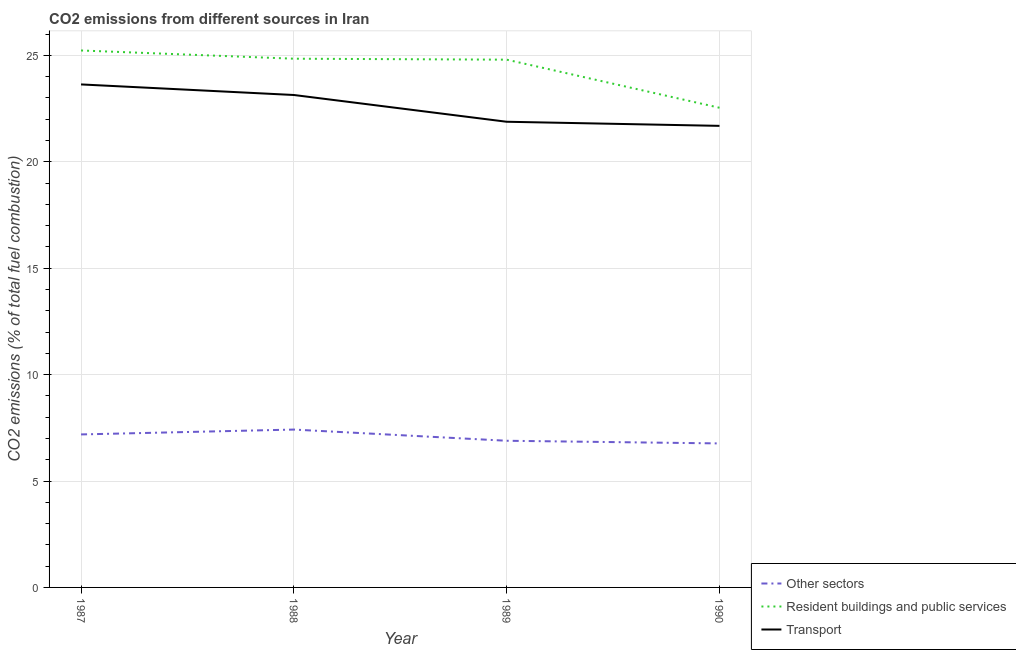What is the percentage of co2 emissions from other sectors in 1989?
Make the answer very short. 6.89. Across all years, what is the maximum percentage of co2 emissions from resident buildings and public services?
Keep it short and to the point. 25.23. Across all years, what is the minimum percentage of co2 emissions from resident buildings and public services?
Give a very brief answer. 22.54. What is the total percentage of co2 emissions from transport in the graph?
Your answer should be compact. 90.33. What is the difference between the percentage of co2 emissions from other sectors in 1988 and that in 1989?
Your answer should be very brief. 0.53. What is the difference between the percentage of co2 emissions from transport in 1988 and the percentage of co2 emissions from resident buildings and public services in 1987?
Provide a succinct answer. -2.09. What is the average percentage of co2 emissions from resident buildings and public services per year?
Offer a very short reply. 24.35. In the year 1989, what is the difference between the percentage of co2 emissions from other sectors and percentage of co2 emissions from transport?
Give a very brief answer. -14.99. What is the ratio of the percentage of co2 emissions from other sectors in 1988 to that in 1989?
Ensure brevity in your answer.  1.08. What is the difference between the highest and the second highest percentage of co2 emissions from other sectors?
Provide a short and direct response. 0.23. What is the difference between the highest and the lowest percentage of co2 emissions from other sectors?
Offer a very short reply. 0.65. Does the percentage of co2 emissions from other sectors monotonically increase over the years?
Provide a succinct answer. No. Is the percentage of co2 emissions from transport strictly greater than the percentage of co2 emissions from other sectors over the years?
Provide a short and direct response. Yes. How many lines are there?
Provide a succinct answer. 3. What is the difference between two consecutive major ticks on the Y-axis?
Give a very brief answer. 5. Does the graph contain any zero values?
Offer a terse response. No. Does the graph contain grids?
Offer a very short reply. Yes. Where does the legend appear in the graph?
Your answer should be very brief. Bottom right. How are the legend labels stacked?
Your answer should be compact. Vertical. What is the title of the graph?
Offer a terse response. CO2 emissions from different sources in Iran. What is the label or title of the X-axis?
Give a very brief answer. Year. What is the label or title of the Y-axis?
Your response must be concise. CO2 emissions (% of total fuel combustion). What is the CO2 emissions (% of total fuel combustion) of Other sectors in 1987?
Provide a succinct answer. 7.19. What is the CO2 emissions (% of total fuel combustion) in Resident buildings and public services in 1987?
Your answer should be very brief. 25.23. What is the CO2 emissions (% of total fuel combustion) in Transport in 1987?
Offer a very short reply. 23.63. What is the CO2 emissions (% of total fuel combustion) in Other sectors in 1988?
Keep it short and to the point. 7.42. What is the CO2 emissions (% of total fuel combustion) in Resident buildings and public services in 1988?
Provide a succinct answer. 24.84. What is the CO2 emissions (% of total fuel combustion) of Transport in 1988?
Make the answer very short. 23.14. What is the CO2 emissions (% of total fuel combustion) of Other sectors in 1989?
Offer a very short reply. 6.89. What is the CO2 emissions (% of total fuel combustion) of Resident buildings and public services in 1989?
Your answer should be very brief. 24.8. What is the CO2 emissions (% of total fuel combustion) in Transport in 1989?
Provide a succinct answer. 21.88. What is the CO2 emissions (% of total fuel combustion) of Other sectors in 1990?
Give a very brief answer. 6.77. What is the CO2 emissions (% of total fuel combustion) in Resident buildings and public services in 1990?
Ensure brevity in your answer.  22.54. What is the CO2 emissions (% of total fuel combustion) of Transport in 1990?
Your answer should be very brief. 21.69. Across all years, what is the maximum CO2 emissions (% of total fuel combustion) in Other sectors?
Keep it short and to the point. 7.42. Across all years, what is the maximum CO2 emissions (% of total fuel combustion) in Resident buildings and public services?
Offer a terse response. 25.23. Across all years, what is the maximum CO2 emissions (% of total fuel combustion) of Transport?
Provide a succinct answer. 23.63. Across all years, what is the minimum CO2 emissions (% of total fuel combustion) in Other sectors?
Give a very brief answer. 6.77. Across all years, what is the minimum CO2 emissions (% of total fuel combustion) in Resident buildings and public services?
Give a very brief answer. 22.54. Across all years, what is the minimum CO2 emissions (% of total fuel combustion) of Transport?
Offer a terse response. 21.69. What is the total CO2 emissions (% of total fuel combustion) of Other sectors in the graph?
Offer a very short reply. 28.26. What is the total CO2 emissions (% of total fuel combustion) of Resident buildings and public services in the graph?
Your response must be concise. 97.4. What is the total CO2 emissions (% of total fuel combustion) in Transport in the graph?
Make the answer very short. 90.33. What is the difference between the CO2 emissions (% of total fuel combustion) in Other sectors in 1987 and that in 1988?
Offer a terse response. -0.23. What is the difference between the CO2 emissions (% of total fuel combustion) in Resident buildings and public services in 1987 and that in 1988?
Keep it short and to the point. 0.39. What is the difference between the CO2 emissions (% of total fuel combustion) in Transport in 1987 and that in 1988?
Your response must be concise. 0.5. What is the difference between the CO2 emissions (% of total fuel combustion) in Other sectors in 1987 and that in 1989?
Your answer should be compact. 0.3. What is the difference between the CO2 emissions (% of total fuel combustion) in Resident buildings and public services in 1987 and that in 1989?
Make the answer very short. 0.43. What is the difference between the CO2 emissions (% of total fuel combustion) of Transport in 1987 and that in 1989?
Make the answer very short. 1.75. What is the difference between the CO2 emissions (% of total fuel combustion) in Other sectors in 1987 and that in 1990?
Make the answer very short. 0.42. What is the difference between the CO2 emissions (% of total fuel combustion) in Resident buildings and public services in 1987 and that in 1990?
Keep it short and to the point. 2.69. What is the difference between the CO2 emissions (% of total fuel combustion) in Transport in 1987 and that in 1990?
Offer a terse response. 1.95. What is the difference between the CO2 emissions (% of total fuel combustion) of Other sectors in 1988 and that in 1989?
Provide a succinct answer. 0.53. What is the difference between the CO2 emissions (% of total fuel combustion) of Resident buildings and public services in 1988 and that in 1989?
Ensure brevity in your answer.  0.04. What is the difference between the CO2 emissions (% of total fuel combustion) of Transport in 1988 and that in 1989?
Provide a succinct answer. 1.26. What is the difference between the CO2 emissions (% of total fuel combustion) of Other sectors in 1988 and that in 1990?
Provide a short and direct response. 0.65. What is the difference between the CO2 emissions (% of total fuel combustion) of Resident buildings and public services in 1988 and that in 1990?
Your response must be concise. 2.3. What is the difference between the CO2 emissions (% of total fuel combustion) of Transport in 1988 and that in 1990?
Keep it short and to the point. 1.45. What is the difference between the CO2 emissions (% of total fuel combustion) in Other sectors in 1989 and that in 1990?
Provide a short and direct response. 0.12. What is the difference between the CO2 emissions (% of total fuel combustion) in Resident buildings and public services in 1989 and that in 1990?
Your answer should be very brief. 2.26. What is the difference between the CO2 emissions (% of total fuel combustion) of Transport in 1989 and that in 1990?
Your answer should be compact. 0.19. What is the difference between the CO2 emissions (% of total fuel combustion) in Other sectors in 1987 and the CO2 emissions (% of total fuel combustion) in Resident buildings and public services in 1988?
Your response must be concise. -17.65. What is the difference between the CO2 emissions (% of total fuel combustion) of Other sectors in 1987 and the CO2 emissions (% of total fuel combustion) of Transport in 1988?
Provide a succinct answer. -15.95. What is the difference between the CO2 emissions (% of total fuel combustion) of Resident buildings and public services in 1987 and the CO2 emissions (% of total fuel combustion) of Transport in 1988?
Provide a short and direct response. 2.09. What is the difference between the CO2 emissions (% of total fuel combustion) of Other sectors in 1987 and the CO2 emissions (% of total fuel combustion) of Resident buildings and public services in 1989?
Ensure brevity in your answer.  -17.61. What is the difference between the CO2 emissions (% of total fuel combustion) of Other sectors in 1987 and the CO2 emissions (% of total fuel combustion) of Transport in 1989?
Offer a terse response. -14.69. What is the difference between the CO2 emissions (% of total fuel combustion) in Resident buildings and public services in 1987 and the CO2 emissions (% of total fuel combustion) in Transport in 1989?
Ensure brevity in your answer.  3.35. What is the difference between the CO2 emissions (% of total fuel combustion) of Other sectors in 1987 and the CO2 emissions (% of total fuel combustion) of Resident buildings and public services in 1990?
Keep it short and to the point. -15.35. What is the difference between the CO2 emissions (% of total fuel combustion) in Other sectors in 1987 and the CO2 emissions (% of total fuel combustion) in Transport in 1990?
Ensure brevity in your answer.  -14.5. What is the difference between the CO2 emissions (% of total fuel combustion) in Resident buildings and public services in 1987 and the CO2 emissions (% of total fuel combustion) in Transport in 1990?
Your response must be concise. 3.54. What is the difference between the CO2 emissions (% of total fuel combustion) in Other sectors in 1988 and the CO2 emissions (% of total fuel combustion) in Resident buildings and public services in 1989?
Your response must be concise. -17.38. What is the difference between the CO2 emissions (% of total fuel combustion) in Other sectors in 1988 and the CO2 emissions (% of total fuel combustion) in Transport in 1989?
Ensure brevity in your answer.  -14.46. What is the difference between the CO2 emissions (% of total fuel combustion) in Resident buildings and public services in 1988 and the CO2 emissions (% of total fuel combustion) in Transport in 1989?
Your answer should be compact. 2.96. What is the difference between the CO2 emissions (% of total fuel combustion) of Other sectors in 1988 and the CO2 emissions (% of total fuel combustion) of Resident buildings and public services in 1990?
Keep it short and to the point. -15.12. What is the difference between the CO2 emissions (% of total fuel combustion) in Other sectors in 1988 and the CO2 emissions (% of total fuel combustion) in Transport in 1990?
Your answer should be very brief. -14.27. What is the difference between the CO2 emissions (% of total fuel combustion) in Resident buildings and public services in 1988 and the CO2 emissions (% of total fuel combustion) in Transport in 1990?
Keep it short and to the point. 3.15. What is the difference between the CO2 emissions (% of total fuel combustion) of Other sectors in 1989 and the CO2 emissions (% of total fuel combustion) of Resident buildings and public services in 1990?
Provide a short and direct response. -15.65. What is the difference between the CO2 emissions (% of total fuel combustion) in Other sectors in 1989 and the CO2 emissions (% of total fuel combustion) in Transport in 1990?
Offer a terse response. -14.79. What is the difference between the CO2 emissions (% of total fuel combustion) of Resident buildings and public services in 1989 and the CO2 emissions (% of total fuel combustion) of Transport in 1990?
Provide a succinct answer. 3.11. What is the average CO2 emissions (% of total fuel combustion) of Other sectors per year?
Offer a terse response. 7.07. What is the average CO2 emissions (% of total fuel combustion) in Resident buildings and public services per year?
Your response must be concise. 24.35. What is the average CO2 emissions (% of total fuel combustion) in Transport per year?
Your answer should be compact. 22.58. In the year 1987, what is the difference between the CO2 emissions (% of total fuel combustion) of Other sectors and CO2 emissions (% of total fuel combustion) of Resident buildings and public services?
Give a very brief answer. -18.04. In the year 1987, what is the difference between the CO2 emissions (% of total fuel combustion) of Other sectors and CO2 emissions (% of total fuel combustion) of Transport?
Your answer should be very brief. -16.44. In the year 1987, what is the difference between the CO2 emissions (% of total fuel combustion) in Resident buildings and public services and CO2 emissions (% of total fuel combustion) in Transport?
Your answer should be compact. 1.6. In the year 1988, what is the difference between the CO2 emissions (% of total fuel combustion) of Other sectors and CO2 emissions (% of total fuel combustion) of Resident buildings and public services?
Offer a terse response. -17.42. In the year 1988, what is the difference between the CO2 emissions (% of total fuel combustion) of Other sectors and CO2 emissions (% of total fuel combustion) of Transport?
Give a very brief answer. -15.72. In the year 1988, what is the difference between the CO2 emissions (% of total fuel combustion) in Resident buildings and public services and CO2 emissions (% of total fuel combustion) in Transport?
Make the answer very short. 1.7. In the year 1989, what is the difference between the CO2 emissions (% of total fuel combustion) in Other sectors and CO2 emissions (% of total fuel combustion) in Resident buildings and public services?
Offer a terse response. -17.91. In the year 1989, what is the difference between the CO2 emissions (% of total fuel combustion) of Other sectors and CO2 emissions (% of total fuel combustion) of Transport?
Your response must be concise. -14.99. In the year 1989, what is the difference between the CO2 emissions (% of total fuel combustion) in Resident buildings and public services and CO2 emissions (% of total fuel combustion) in Transport?
Keep it short and to the point. 2.92. In the year 1990, what is the difference between the CO2 emissions (% of total fuel combustion) in Other sectors and CO2 emissions (% of total fuel combustion) in Resident buildings and public services?
Offer a terse response. -15.77. In the year 1990, what is the difference between the CO2 emissions (% of total fuel combustion) in Other sectors and CO2 emissions (% of total fuel combustion) in Transport?
Provide a short and direct response. -14.92. In the year 1990, what is the difference between the CO2 emissions (% of total fuel combustion) of Resident buildings and public services and CO2 emissions (% of total fuel combustion) of Transport?
Your answer should be very brief. 0.85. What is the ratio of the CO2 emissions (% of total fuel combustion) in Other sectors in 1987 to that in 1988?
Ensure brevity in your answer.  0.97. What is the ratio of the CO2 emissions (% of total fuel combustion) in Resident buildings and public services in 1987 to that in 1988?
Your answer should be compact. 1.02. What is the ratio of the CO2 emissions (% of total fuel combustion) in Transport in 1987 to that in 1988?
Offer a terse response. 1.02. What is the ratio of the CO2 emissions (% of total fuel combustion) of Other sectors in 1987 to that in 1989?
Keep it short and to the point. 1.04. What is the ratio of the CO2 emissions (% of total fuel combustion) of Resident buildings and public services in 1987 to that in 1989?
Ensure brevity in your answer.  1.02. What is the ratio of the CO2 emissions (% of total fuel combustion) in Transport in 1987 to that in 1989?
Provide a short and direct response. 1.08. What is the ratio of the CO2 emissions (% of total fuel combustion) in Other sectors in 1987 to that in 1990?
Offer a very short reply. 1.06. What is the ratio of the CO2 emissions (% of total fuel combustion) of Resident buildings and public services in 1987 to that in 1990?
Provide a short and direct response. 1.12. What is the ratio of the CO2 emissions (% of total fuel combustion) in Transport in 1987 to that in 1990?
Your answer should be compact. 1.09. What is the ratio of the CO2 emissions (% of total fuel combustion) of Other sectors in 1988 to that in 1989?
Your answer should be very brief. 1.08. What is the ratio of the CO2 emissions (% of total fuel combustion) of Resident buildings and public services in 1988 to that in 1989?
Keep it short and to the point. 1. What is the ratio of the CO2 emissions (% of total fuel combustion) in Transport in 1988 to that in 1989?
Provide a succinct answer. 1.06. What is the ratio of the CO2 emissions (% of total fuel combustion) of Other sectors in 1988 to that in 1990?
Your response must be concise. 1.1. What is the ratio of the CO2 emissions (% of total fuel combustion) in Resident buildings and public services in 1988 to that in 1990?
Your answer should be compact. 1.1. What is the ratio of the CO2 emissions (% of total fuel combustion) in Transport in 1988 to that in 1990?
Provide a succinct answer. 1.07. What is the ratio of the CO2 emissions (% of total fuel combustion) in Other sectors in 1989 to that in 1990?
Keep it short and to the point. 1.02. What is the ratio of the CO2 emissions (% of total fuel combustion) in Resident buildings and public services in 1989 to that in 1990?
Provide a succinct answer. 1.1. What is the ratio of the CO2 emissions (% of total fuel combustion) in Transport in 1989 to that in 1990?
Your answer should be compact. 1.01. What is the difference between the highest and the second highest CO2 emissions (% of total fuel combustion) of Other sectors?
Your answer should be compact. 0.23. What is the difference between the highest and the second highest CO2 emissions (% of total fuel combustion) of Resident buildings and public services?
Your answer should be compact. 0.39. What is the difference between the highest and the second highest CO2 emissions (% of total fuel combustion) in Transport?
Give a very brief answer. 0.5. What is the difference between the highest and the lowest CO2 emissions (% of total fuel combustion) in Other sectors?
Make the answer very short. 0.65. What is the difference between the highest and the lowest CO2 emissions (% of total fuel combustion) of Resident buildings and public services?
Provide a short and direct response. 2.69. What is the difference between the highest and the lowest CO2 emissions (% of total fuel combustion) in Transport?
Your answer should be very brief. 1.95. 